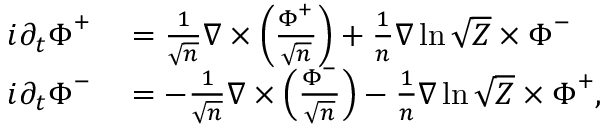Convert formula to latex. <formula><loc_0><loc_0><loc_500><loc_500>\begin{array} { r l } { i \partial _ { t } \Phi ^ { + } } & = \frac { 1 } { \sqrt { n } } \nabla \times \left ( \frac { \Phi ^ { + } } { \sqrt { n } } \right ) + \frac { 1 } { n } \nabla \ln \sqrt { Z } \times \Phi ^ { - } } \\ { i \partial _ { t } \Phi ^ { - } } & = - \frac { 1 } { \sqrt { n } } \nabla \times \left ( \frac { \Phi ^ { - } } { \sqrt { n } } \right ) - \frac { 1 } { n } \nabla \ln \sqrt { Z } \times \Phi ^ { + } , } \end{array}</formula> 